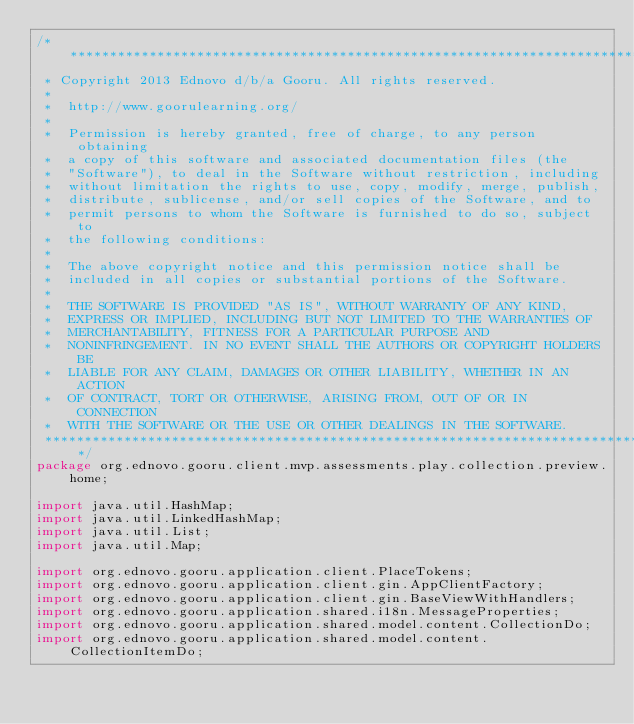Convert code to text. <code><loc_0><loc_0><loc_500><loc_500><_Java_>/*******************************************************************************
 * Copyright 2013 Ednovo d/b/a Gooru. All rights reserved.
 *
 *  http://www.goorulearning.org/
 *
 *  Permission is hereby granted, free of charge, to any person obtaining
 *  a copy of this software and associated documentation files (the
 *  "Software"), to deal in the Software without restriction, including
 *  without limitation the rights to use, copy, modify, merge, publish,
 *  distribute, sublicense, and/or sell copies of the Software, and to
 *  permit persons to whom the Software is furnished to do so, subject to
 *  the following conditions:
 *
 *  The above copyright notice and this permission notice shall be
 *  included in all copies or substantial portions of the Software.
 *
 *  THE SOFTWARE IS PROVIDED "AS IS", WITHOUT WARRANTY OF ANY KIND,
 *  EXPRESS OR IMPLIED, INCLUDING BUT NOT LIMITED TO THE WARRANTIES OF
 *  MERCHANTABILITY, FITNESS FOR A PARTICULAR PURPOSE AND
 *  NONINFRINGEMENT. IN NO EVENT SHALL THE AUTHORS OR COPYRIGHT HOLDERS BE
 *  LIABLE FOR ANY CLAIM, DAMAGES OR OTHER LIABILITY, WHETHER IN AN ACTION
 *  OF CONTRACT, TORT OR OTHERWISE, ARISING FROM, OUT OF OR IN CONNECTION
 *  WITH THE SOFTWARE OR THE USE OR OTHER DEALINGS IN THE SOFTWARE.
 ******************************************************************************/
package org.ednovo.gooru.client.mvp.assessments.play.collection.preview.home;

import java.util.HashMap;
import java.util.LinkedHashMap;
import java.util.List;
import java.util.Map;

import org.ednovo.gooru.application.client.PlaceTokens;
import org.ednovo.gooru.application.client.gin.AppClientFactory;
import org.ednovo.gooru.application.client.gin.BaseViewWithHandlers;
import org.ednovo.gooru.application.shared.i18n.MessageProperties;
import org.ednovo.gooru.application.shared.model.content.CollectionDo;
import org.ednovo.gooru.application.shared.model.content.CollectionItemDo;</code> 